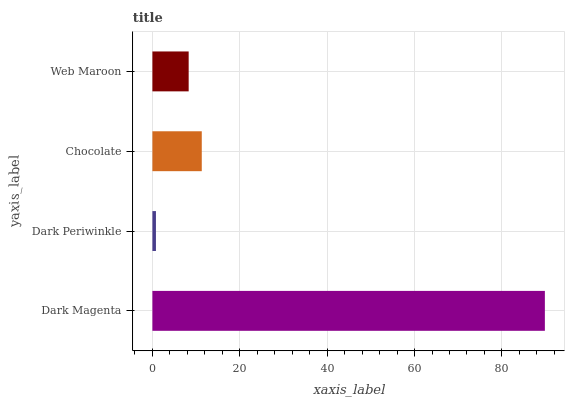Is Dark Periwinkle the minimum?
Answer yes or no. Yes. Is Dark Magenta the maximum?
Answer yes or no. Yes. Is Chocolate the minimum?
Answer yes or no. No. Is Chocolate the maximum?
Answer yes or no. No. Is Chocolate greater than Dark Periwinkle?
Answer yes or no. Yes. Is Dark Periwinkle less than Chocolate?
Answer yes or no. Yes. Is Dark Periwinkle greater than Chocolate?
Answer yes or no. No. Is Chocolate less than Dark Periwinkle?
Answer yes or no. No. Is Chocolate the high median?
Answer yes or no. Yes. Is Web Maroon the low median?
Answer yes or no. Yes. Is Dark Periwinkle the high median?
Answer yes or no. No. Is Dark Magenta the low median?
Answer yes or no. No. 